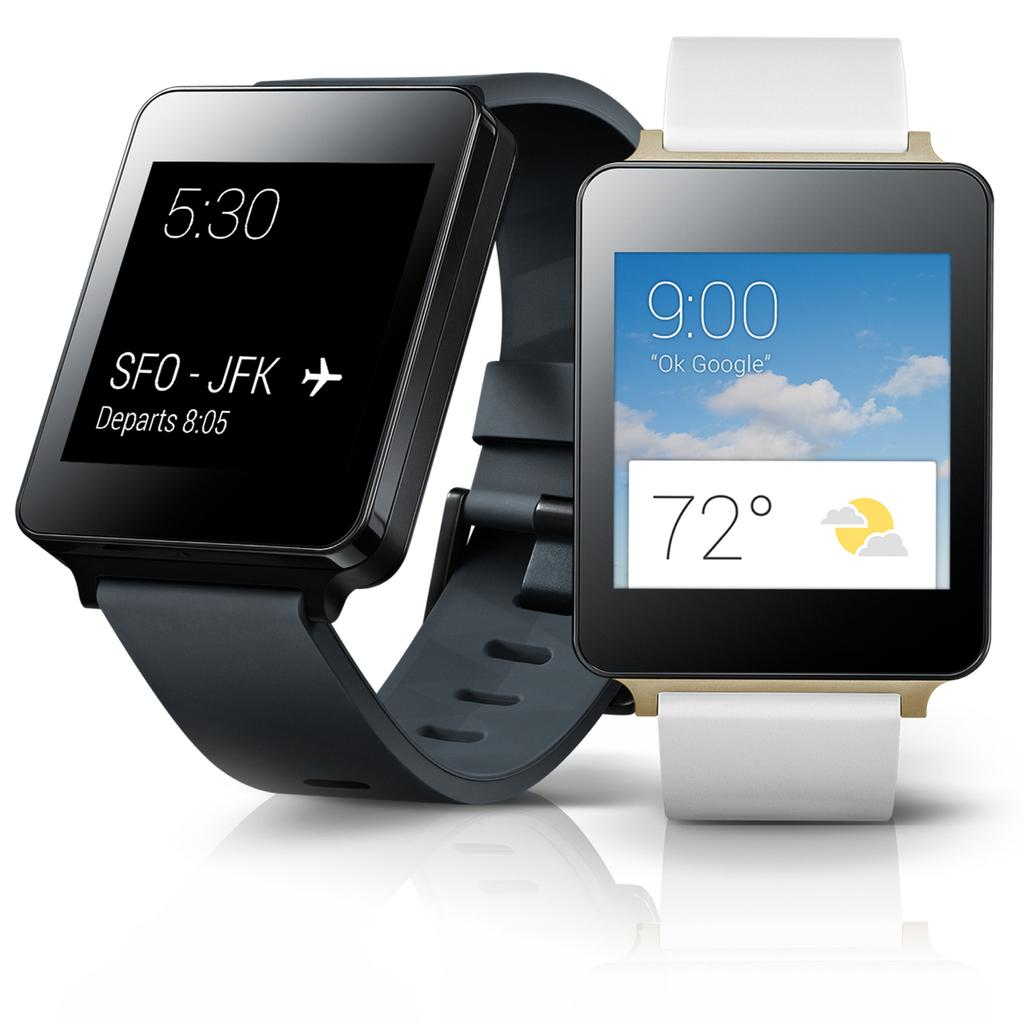<image>
Present a compact description of the photo's key features. the time is 9:00 on the front of a watch 